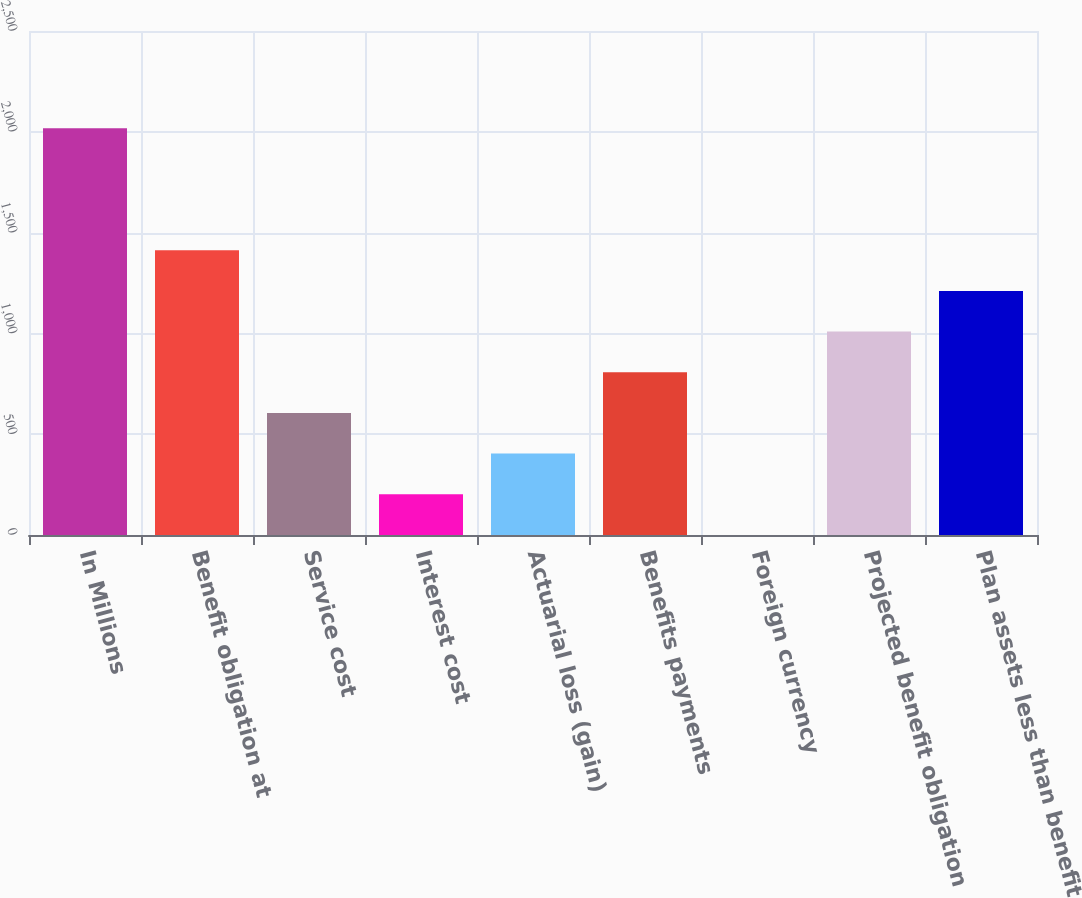<chart> <loc_0><loc_0><loc_500><loc_500><bar_chart><fcel>In Millions<fcel>Benefit obligation at<fcel>Service cost<fcel>Interest cost<fcel>Actuarial loss (gain)<fcel>Benefits payments<fcel>Foreign currency<fcel>Projected benefit obligation<fcel>Plan assets less than benefit<nl><fcel>2018<fcel>1412.66<fcel>605.54<fcel>201.98<fcel>403.76<fcel>807.32<fcel>0.2<fcel>1009.1<fcel>1210.88<nl></chart> 